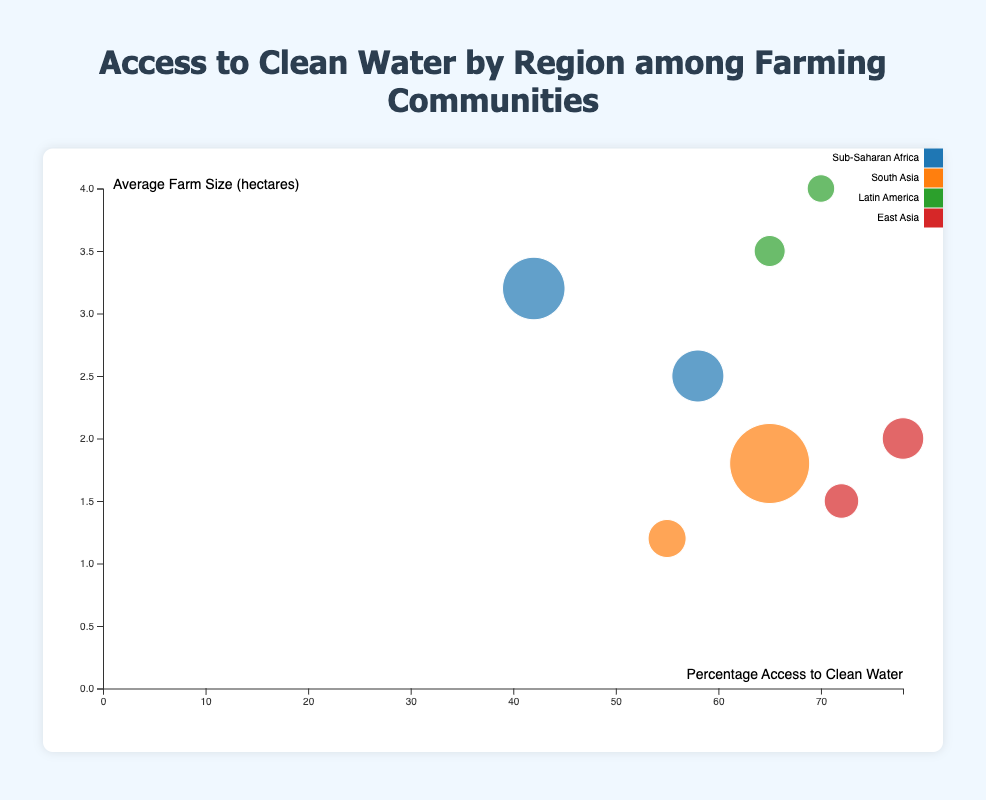What is the title of the chart? The title of the chart is generally displayed prominently at the top, providing a clear description of the figure's content.
Answer: "Access to Clean Water by Region among Farming Communities" Which axis represents the Percentage Access to Clean Water? The Percentage Access to Clean Water is labeled on the axis at the bottom of the chart. The label "Percentage Access to Clean Water" indicates the horizontal axis.
Answer: The horizontal axis (x-axis) How many data points represent East Asia? Each bubble's color represents a different region. By counting the bubbles with the same color attributed to East Asia (as shown in the legend), we can identify the data points.
Answer: 2 Which country has the highest Percentage Access to Clean Water? By tracing the axis representing Percentage Access to Clean Water and identifying the country that aligns with the highest value on this axis, we find the country.
Answer: Vietnam What is the average farm size in Guatemala? The country Guatemala can be identified via its bubble, and the vertical axis labeled "Average Farm Size (hectares)" shows the corresponding value for that data point.
Answer: 4.0 hectares Compare the access to clean water for Kenya and Ethiopia. Which country has better access? By looking at the horizontal positions of the bubbles for Kenya and Ethiopia, the country whose bubble aligns farther to the right on the x-axis has better access.
Answer: Kenya What is the Farming Community Population in India? The size of the bubble represents the Farming Community Population. The larger the bubble, the larger the population. By referencing the bubble size scale provided, we identify India's population.
Answer: 20,000 Which region has the lowest range in average farm size among its countries? By comparing the vertical spread (y-axis) of bubbles within each region’s bubbles, we can determine the extent of variation in average farm size. The region with the least vertical spread has the lowest range.
Answer: South Asia Is there a positive correlation between Average Farm Size and Percentage Access to Clean Water? By observing the overall trend in the distribution of the bubbles relative to both the x and y axes, a positive correlation would show bubbles generally moving upwards as they move right.
Answer: No Which region has the largest bubbles overall, and what does this indicate? The legend associates bubble color with regions, and by identifying the region with the largest average bubble sizes, we can infer that this region has the largest farming populations.
Answer: South Asia 